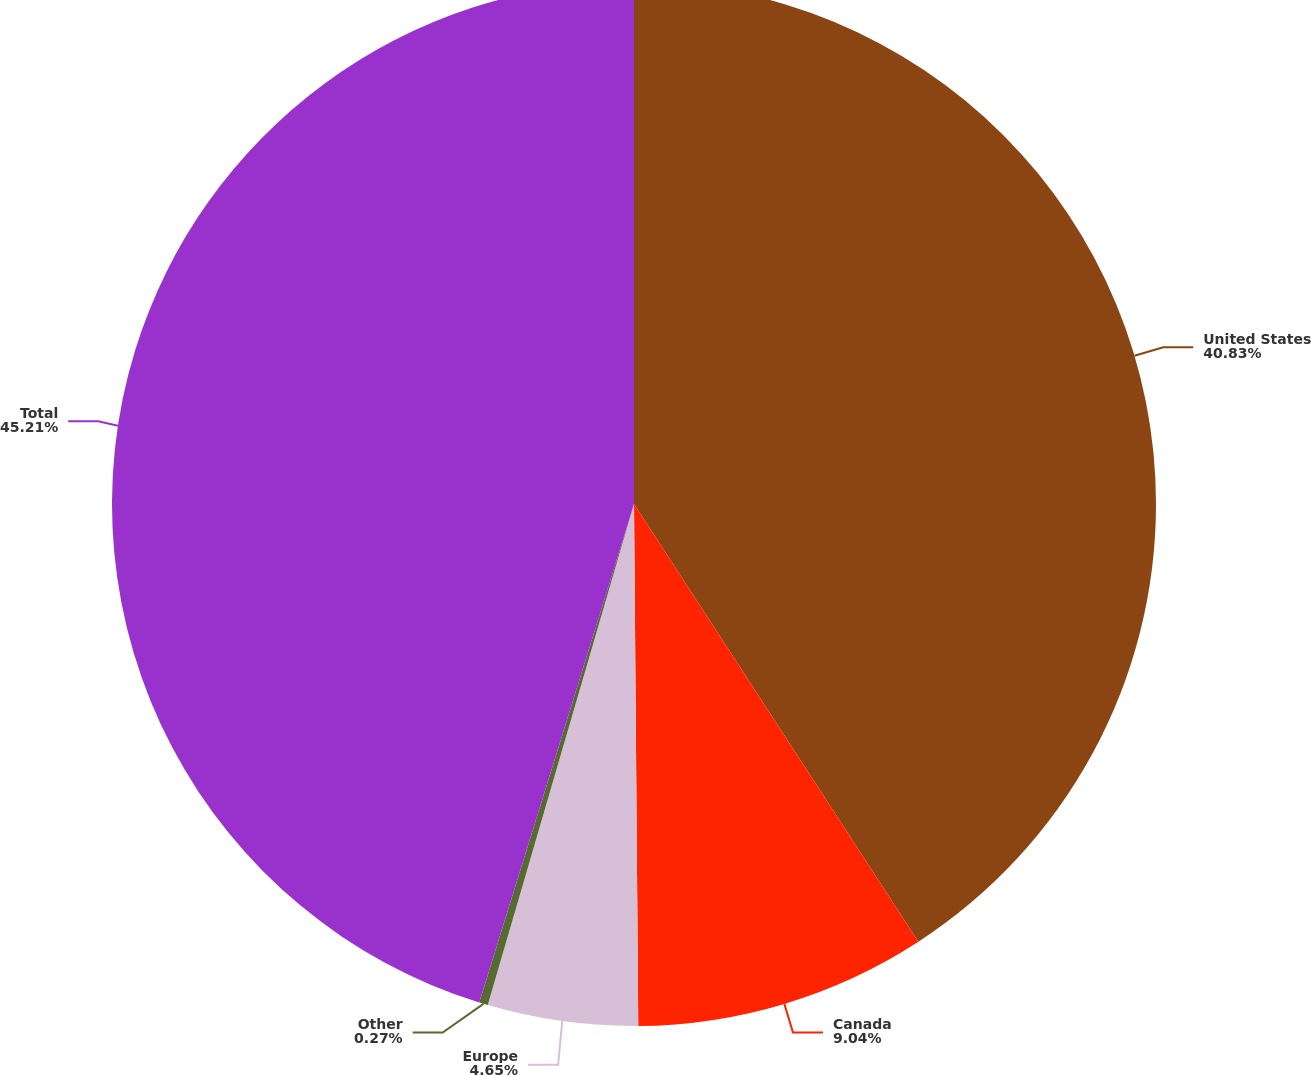<chart> <loc_0><loc_0><loc_500><loc_500><pie_chart><fcel>United States<fcel>Canada<fcel>Europe<fcel>Other<fcel>Total<nl><fcel>40.83%<fcel>9.04%<fcel>4.65%<fcel>0.27%<fcel>45.21%<nl></chart> 